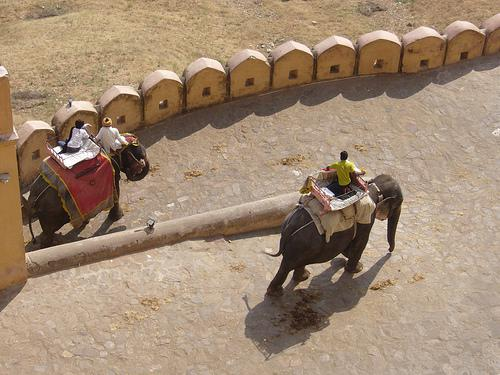Question: what animal is seen?
Choices:
A. Elephant.
B. Zebra.
C. Horse.
D. Frog.
Answer with the letter. Answer: A Question: what is the color of the elephant?
Choices:
A. Blue.
B. Pink.
C. Black.
D. Grey.
Answer with the letter. Answer: D Question: how many elephants are there?
Choices:
A. 2.
B. 3.
C. 4.
D. 5.
Answer with the letter. Answer: A Question: what are the people doing on elephant?
Choices:
A. Standing.
B. Eating.
C. Sitting.
D. Praying.
Answer with the letter. Answer: C 